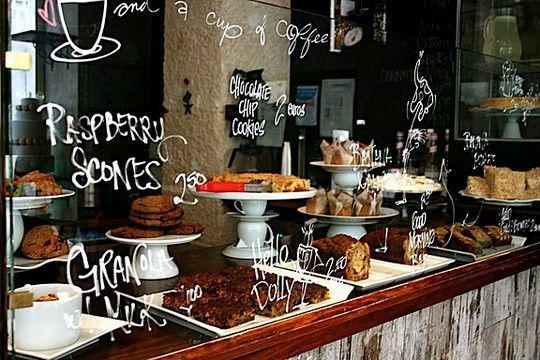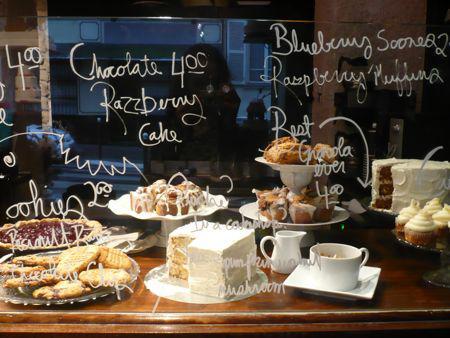The first image is the image on the left, the second image is the image on the right. Analyze the images presented: Is the assertion "At least one photo shows a menu that is hand-written and a variety of sweets on pedestals of different heights." valid? Answer yes or no. Yes. The first image is the image on the left, the second image is the image on the right. Assess this claim about the two images: "In at least one image there are at least 4 strawberry slices in backed mix.". Correct or not? Answer yes or no. No. 